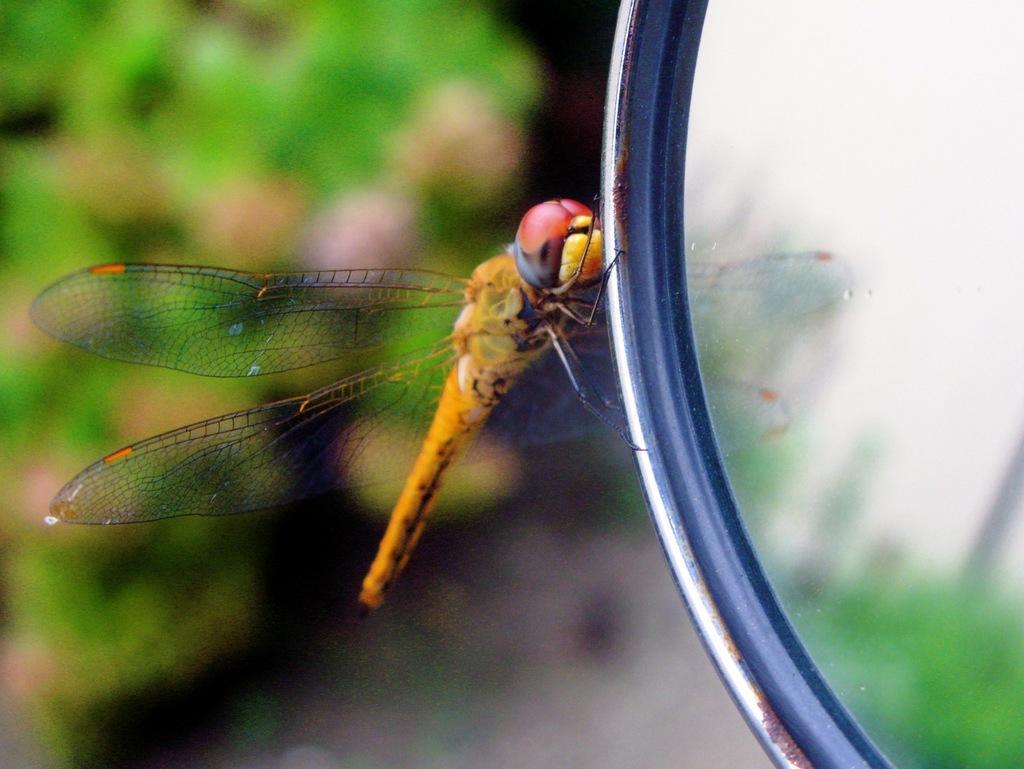Could you give a brief overview of what you see in this image? On the right side of this image there is a mirror and there is a dragonfly on it. The background is blurred. 